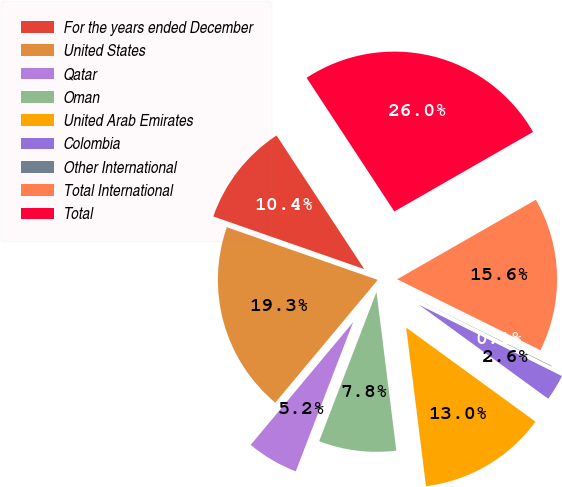<chart> <loc_0><loc_0><loc_500><loc_500><pie_chart><fcel>For the years ended December<fcel>United States<fcel>Qatar<fcel>Oman<fcel>United Arab Emirates<fcel>Colombia<fcel>Other International<fcel>Total International<fcel>Total<nl><fcel>10.41%<fcel>19.27%<fcel>5.23%<fcel>7.82%<fcel>13.01%<fcel>2.64%<fcel>0.05%<fcel>15.6%<fcel>25.96%<nl></chart> 